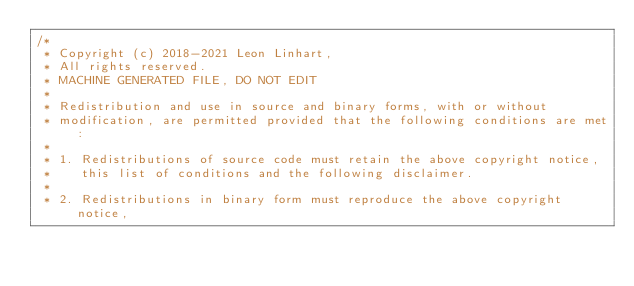<code> <loc_0><loc_0><loc_500><loc_500><_Java_>/*
 * Copyright (c) 2018-2021 Leon Linhart,
 * All rights reserved.
 * MACHINE GENERATED FILE, DO NOT EDIT
 *
 * Redistribution and use in source and binary forms, with or without
 * modification, are permitted provided that the following conditions are met:
 *
 * 1. Redistributions of source code must retain the above copyright notice,
 *    this list of conditions and the following disclaimer.
 *
 * 2. Redistributions in binary form must reproduce the above copyright notice,</code> 